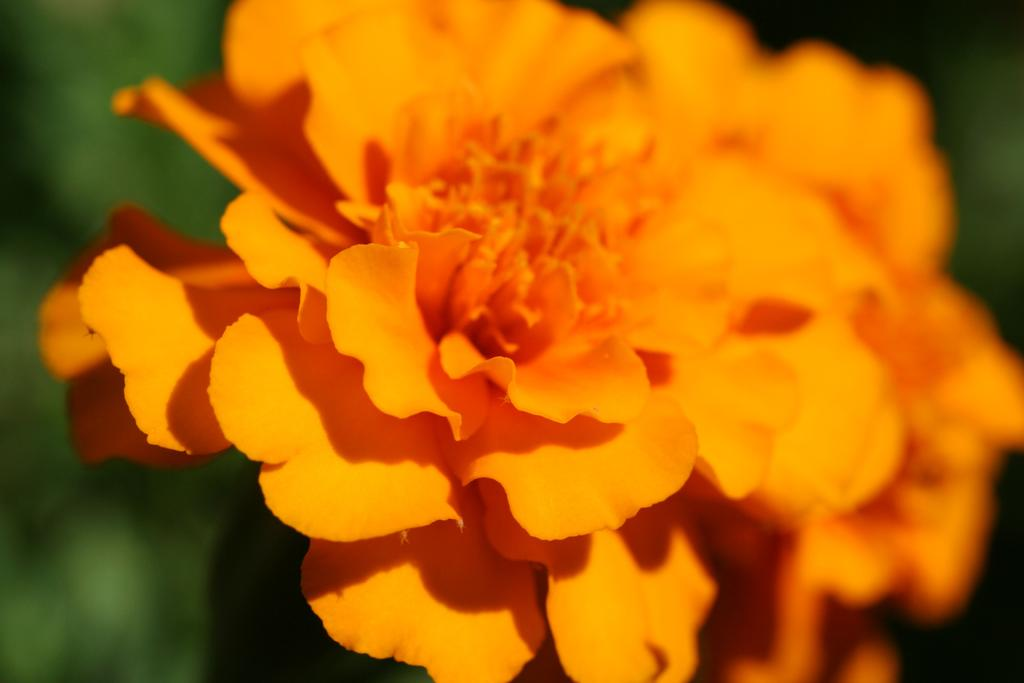What is the main subject of the image? There is a plant in the image. What color are the flowers on the plant? The plant has yellow flowers. Can you describe the background of the image? The background of the image is blurred. What type of body is visible in the image? There is no body present in the image; it features a plant with yellow flowers and a blurred background. What addition can be made to the plant to make it more appealing? The question assumes that an addition is needed, but the image does not suggest any missing elements. The plant already has yellow flowers, which are visually appealing. 